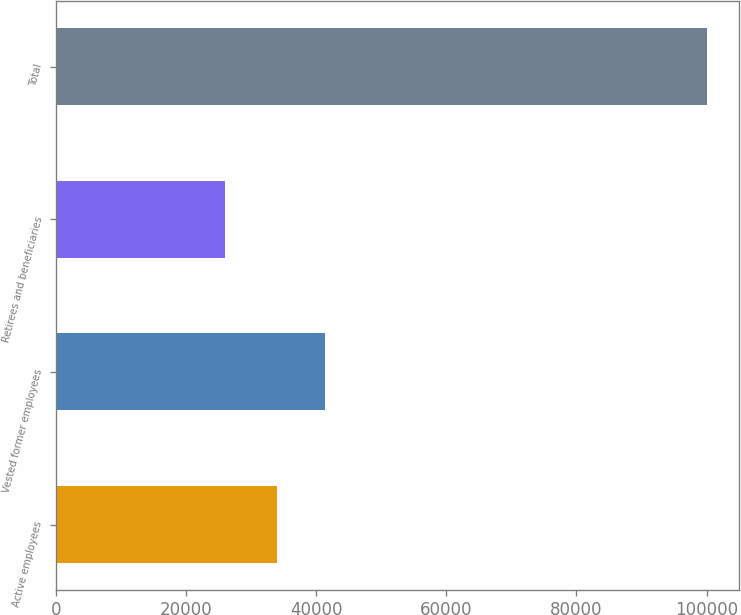Convert chart to OTSL. <chart><loc_0><loc_0><loc_500><loc_500><bar_chart><fcel>Active employees<fcel>Vested former employees<fcel>Retirees and beneficiaries<fcel>Total<nl><fcel>34000<fcel>41400<fcel>26000<fcel>100000<nl></chart> 